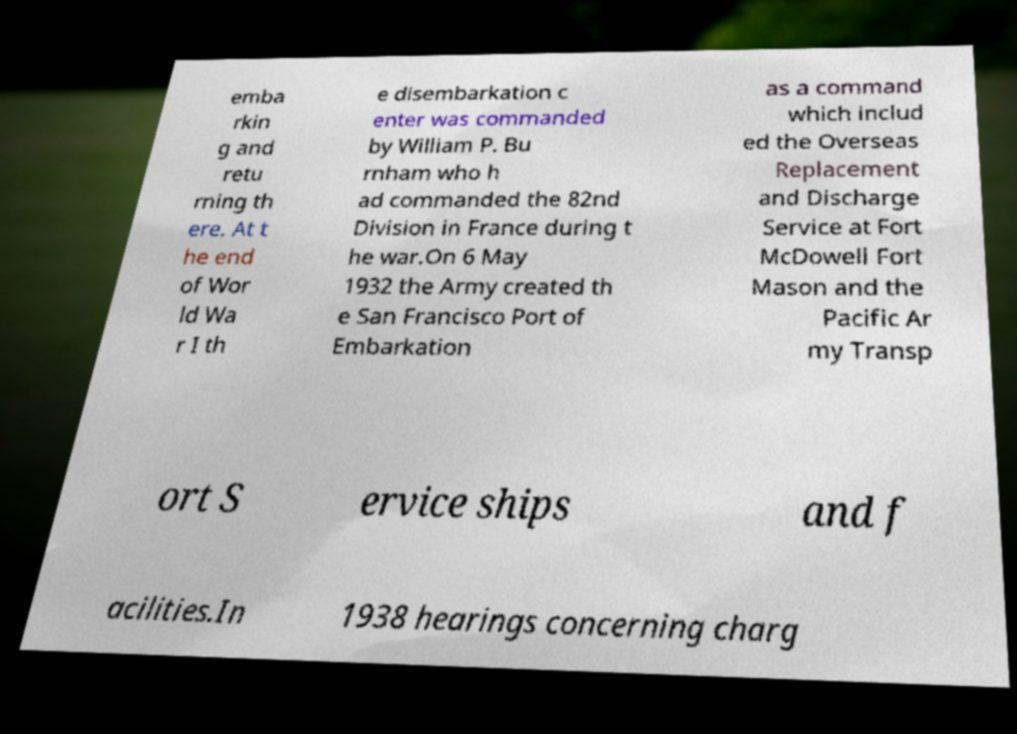There's text embedded in this image that I need extracted. Can you transcribe it verbatim? emba rkin g and retu rning th ere. At t he end of Wor ld Wa r I th e disembarkation c enter was commanded by William P. Bu rnham who h ad commanded the 82nd Division in France during t he war.On 6 May 1932 the Army created th e San Francisco Port of Embarkation as a command which includ ed the Overseas Replacement and Discharge Service at Fort McDowell Fort Mason and the Pacific Ar my Transp ort S ervice ships and f acilities.In 1938 hearings concerning charg 